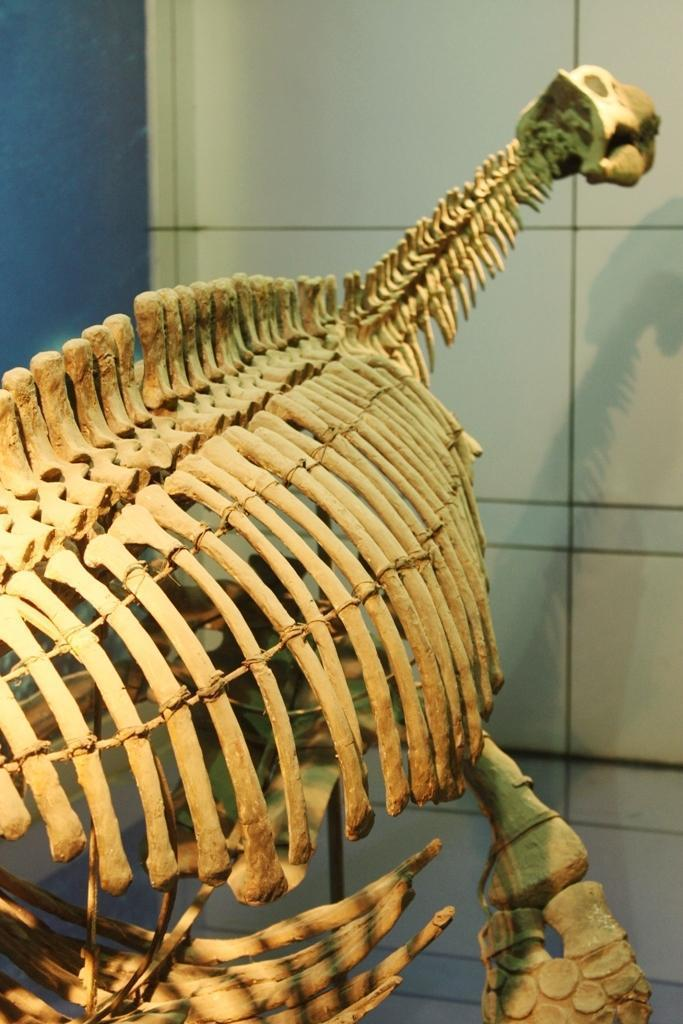What is the main subject of the image? There is a skeleton in the image. What type of cable can be seen connecting the skeleton to the mountain in the image? There is no cable or mountain present in the image; it only features a skeleton. What songs is the skeleton singing in the image? There are no songs or sounds in the image, as it is a still image of a skeleton. 